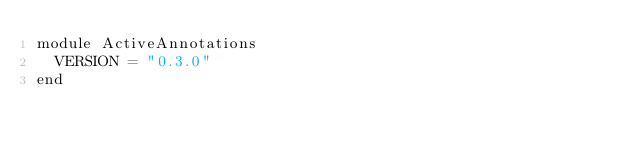Convert code to text. <code><loc_0><loc_0><loc_500><loc_500><_Ruby_>module ActiveAnnotations
  VERSION = "0.3.0"
end
</code> 